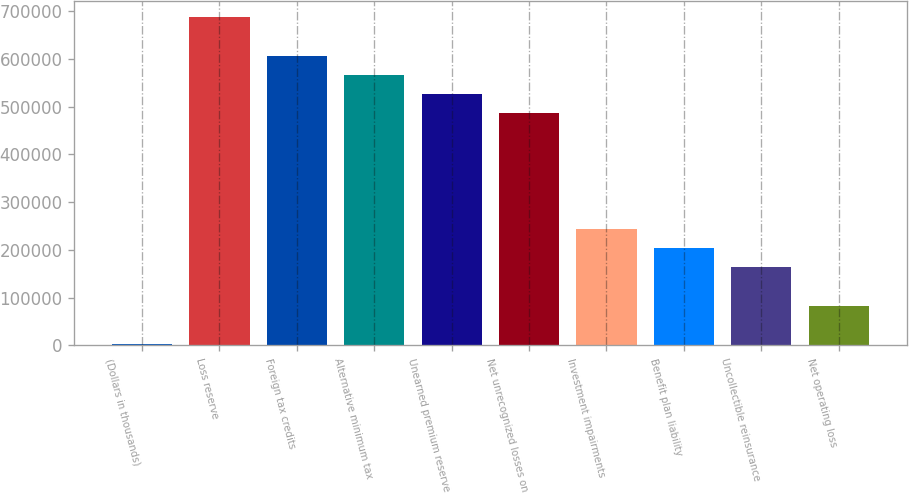<chart> <loc_0><loc_0><loc_500><loc_500><bar_chart><fcel>(Dollars in thousands)<fcel>Loss reserve<fcel>Foreign tax credits<fcel>Alternative minimum tax<fcel>Unearned premium reserve<fcel>Net unrecognized losses on<fcel>Investment impairments<fcel>Benefit plan liability<fcel>Uncollectible reinsurance<fcel>Net operating loss<nl><fcel>2014<fcel>687369<fcel>606739<fcel>566424<fcel>526109<fcel>485794<fcel>243904<fcel>203589<fcel>163274<fcel>82644<nl></chart> 